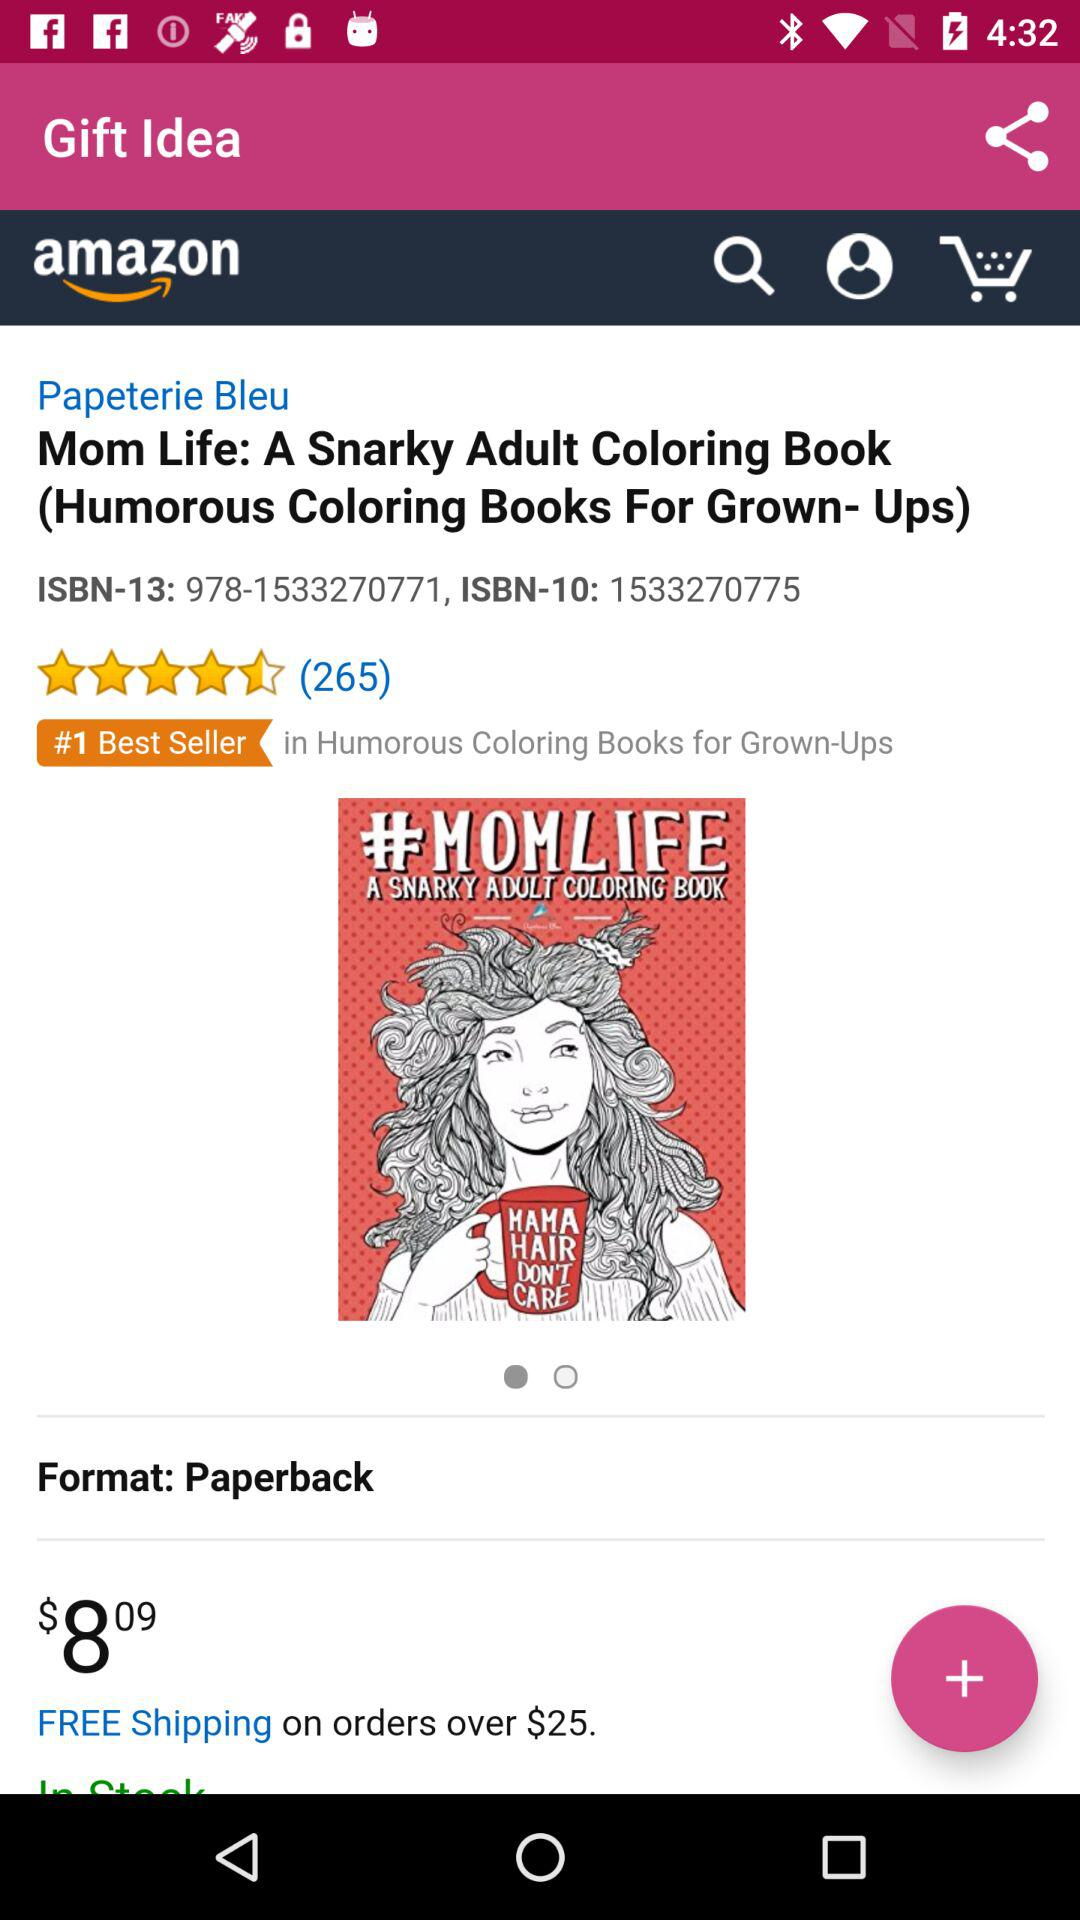How many stars are given to "Mom Life: A Snarky Adult Coloring Book"? There are 4.5 stars given to "Mom Life: A Snarky Adult Coloring Book". 